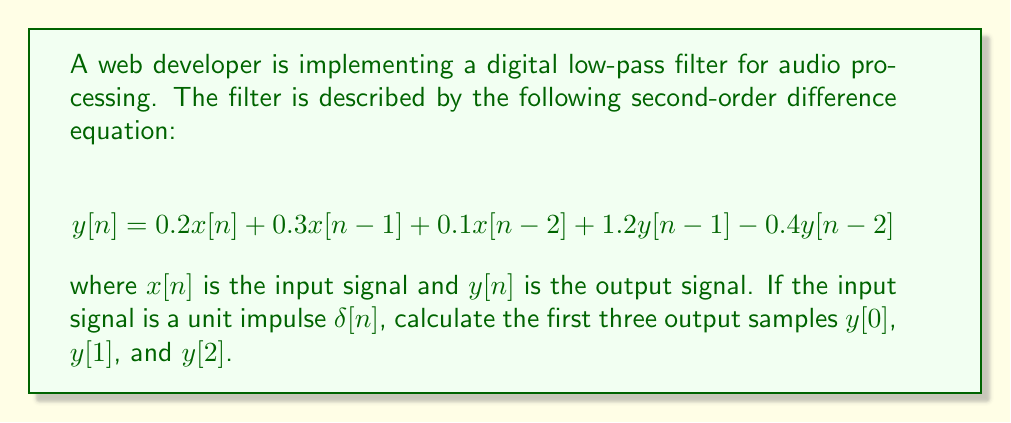Help me with this question. To solve this problem, we need to apply the given difference equation for $n = 0$, $n = 1$, and $n = 2$. Let's go through it step by step:

1. For a unit impulse input $\delta[n]$, we have:
   $x[0] = 1$, and $x[n] = 0$ for all $n \neq 0$

2. We also assume that the system is initially at rest, meaning:
   $x[-1] = x[-2] = y[-1] = y[-2] = 0$

3. Now, let's calculate $y[0]$:
   $y[0] = 0.2x[0] + 0.3x[-1] + 0.1x[-2] + 1.2y[-1] - 0.4y[-2]$
   $y[0] = 0.2(1) + 0.3(0) + 0.1(0) + 1.2(0) - 0.4(0) = 0.2$

4. For $y[1]$:
   $y[1] = 0.2x[1] + 0.3x[0] + 0.1x[-1] + 1.2y[0] - 0.4y[-1]$
   $y[1] = 0.2(0) + 0.3(1) + 0.1(0) + 1.2(0.2) - 0.4(0) = 0.54$

5. For $y[2]$:
   $y[2] = 0.2x[2] + 0.3x[1] + 0.1x[0] + 1.2y[1] - 0.4y[0]$
   $y[2] = 0.2(0) + 0.3(0) + 0.1(1) + 1.2(0.54) - 0.4(0.2) = 0.728$

Therefore, the first three output samples are $y[0] = 0.2$, $y[1] = 0.54$, and $y[2] = 0.728$.
Answer: $y[0] = 0.2$, $y[1] = 0.54$, $y[2] = 0.728$ 